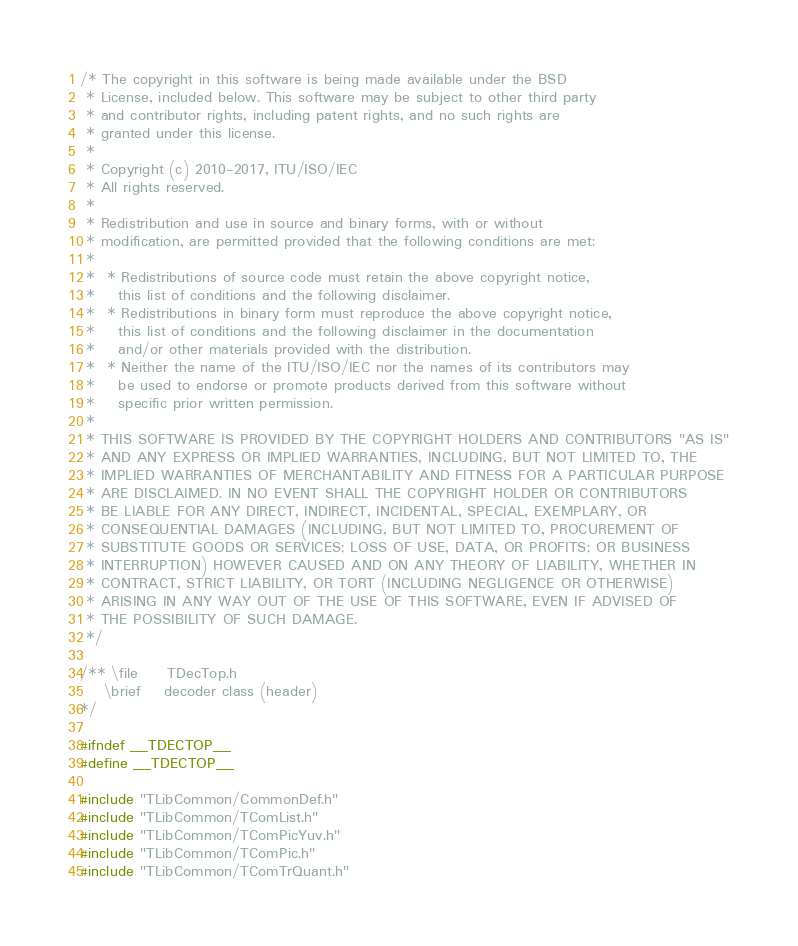<code> <loc_0><loc_0><loc_500><loc_500><_C_>/* The copyright in this software is being made available under the BSD
 * License, included below. This software may be subject to other third party
 * and contributor rights, including patent rights, and no such rights are
 * granted under this license.
 *
 * Copyright (c) 2010-2017, ITU/ISO/IEC
 * All rights reserved.
 *
 * Redistribution and use in source and binary forms, with or without
 * modification, are permitted provided that the following conditions are met:
 *
 *  * Redistributions of source code must retain the above copyright notice,
 *    this list of conditions and the following disclaimer.
 *  * Redistributions in binary form must reproduce the above copyright notice,
 *    this list of conditions and the following disclaimer in the documentation
 *    and/or other materials provided with the distribution.
 *  * Neither the name of the ITU/ISO/IEC nor the names of its contributors may
 *    be used to endorse or promote products derived from this software without
 *    specific prior written permission.
 *
 * THIS SOFTWARE IS PROVIDED BY THE COPYRIGHT HOLDERS AND CONTRIBUTORS "AS IS"
 * AND ANY EXPRESS OR IMPLIED WARRANTIES, INCLUDING, BUT NOT LIMITED TO, THE
 * IMPLIED WARRANTIES OF MERCHANTABILITY AND FITNESS FOR A PARTICULAR PURPOSE
 * ARE DISCLAIMED. IN NO EVENT SHALL THE COPYRIGHT HOLDER OR CONTRIBUTORS
 * BE LIABLE FOR ANY DIRECT, INDIRECT, INCIDENTAL, SPECIAL, EXEMPLARY, OR
 * CONSEQUENTIAL DAMAGES (INCLUDING, BUT NOT LIMITED TO, PROCUREMENT OF
 * SUBSTITUTE GOODS OR SERVICES; LOSS OF USE, DATA, OR PROFITS; OR BUSINESS
 * INTERRUPTION) HOWEVER CAUSED AND ON ANY THEORY OF LIABILITY, WHETHER IN
 * CONTRACT, STRICT LIABILITY, OR TORT (INCLUDING NEGLIGENCE OR OTHERWISE)
 * ARISING IN ANY WAY OUT OF THE USE OF THIS SOFTWARE, EVEN IF ADVISED OF
 * THE POSSIBILITY OF SUCH DAMAGE.
 */

/** \file     TDecTop.h
    \brief    decoder class (header)
*/

#ifndef __TDECTOP__
#define __TDECTOP__

#include "TLibCommon/CommonDef.h"
#include "TLibCommon/TComList.h"
#include "TLibCommon/TComPicYuv.h"
#include "TLibCommon/TComPic.h"
#include "TLibCommon/TComTrQuant.h"</code> 